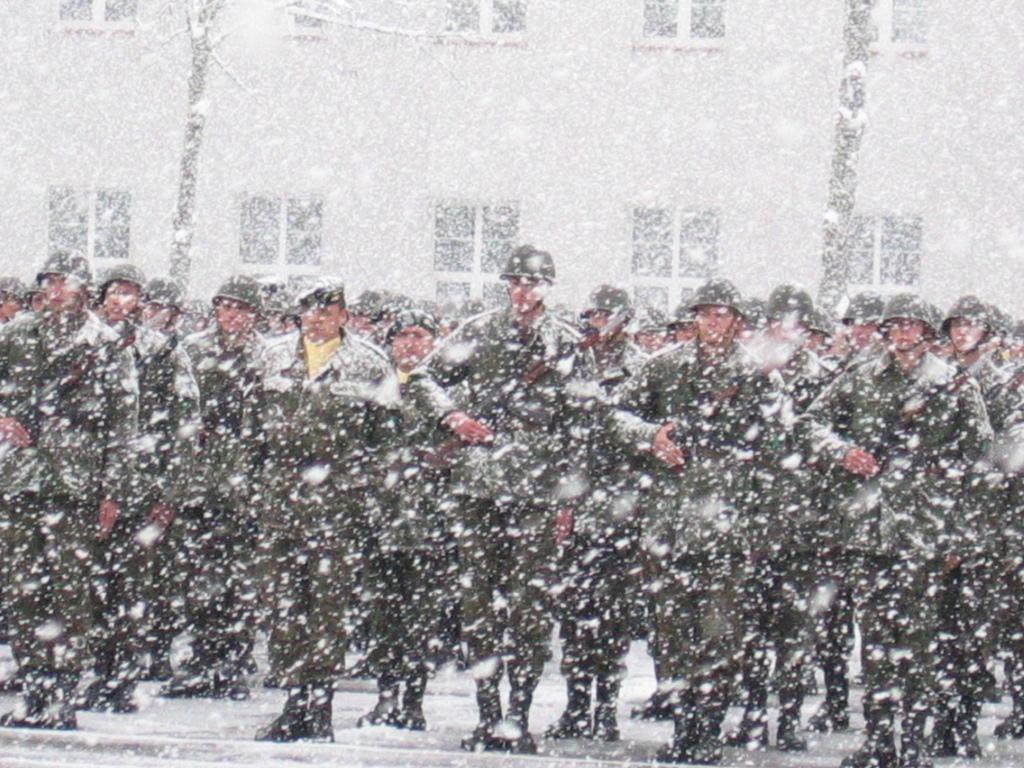Describe this image in one or two sentences. This image consists of many persons wearing helmets are standing on the road. And there is snowfall. In the background, there is a building. 